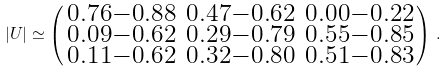Convert formula to latex. <formula><loc_0><loc_0><loc_500><loc_500>| U | \simeq \left ( \begin{smallmatrix} 0 . 7 6 - 0 . 8 8 & 0 . 4 7 - 0 . 6 2 & 0 . 0 0 - 0 . 2 2 \\ 0 . 0 9 - 0 . 6 2 & 0 . 2 9 - 0 . 7 9 & 0 . 5 5 - 0 . 8 5 \\ 0 . 1 1 - 0 . 6 2 & 0 . 3 2 - 0 . 8 0 & 0 . 5 1 - 0 . 8 3 \end{smallmatrix} \right ) \, .</formula> 